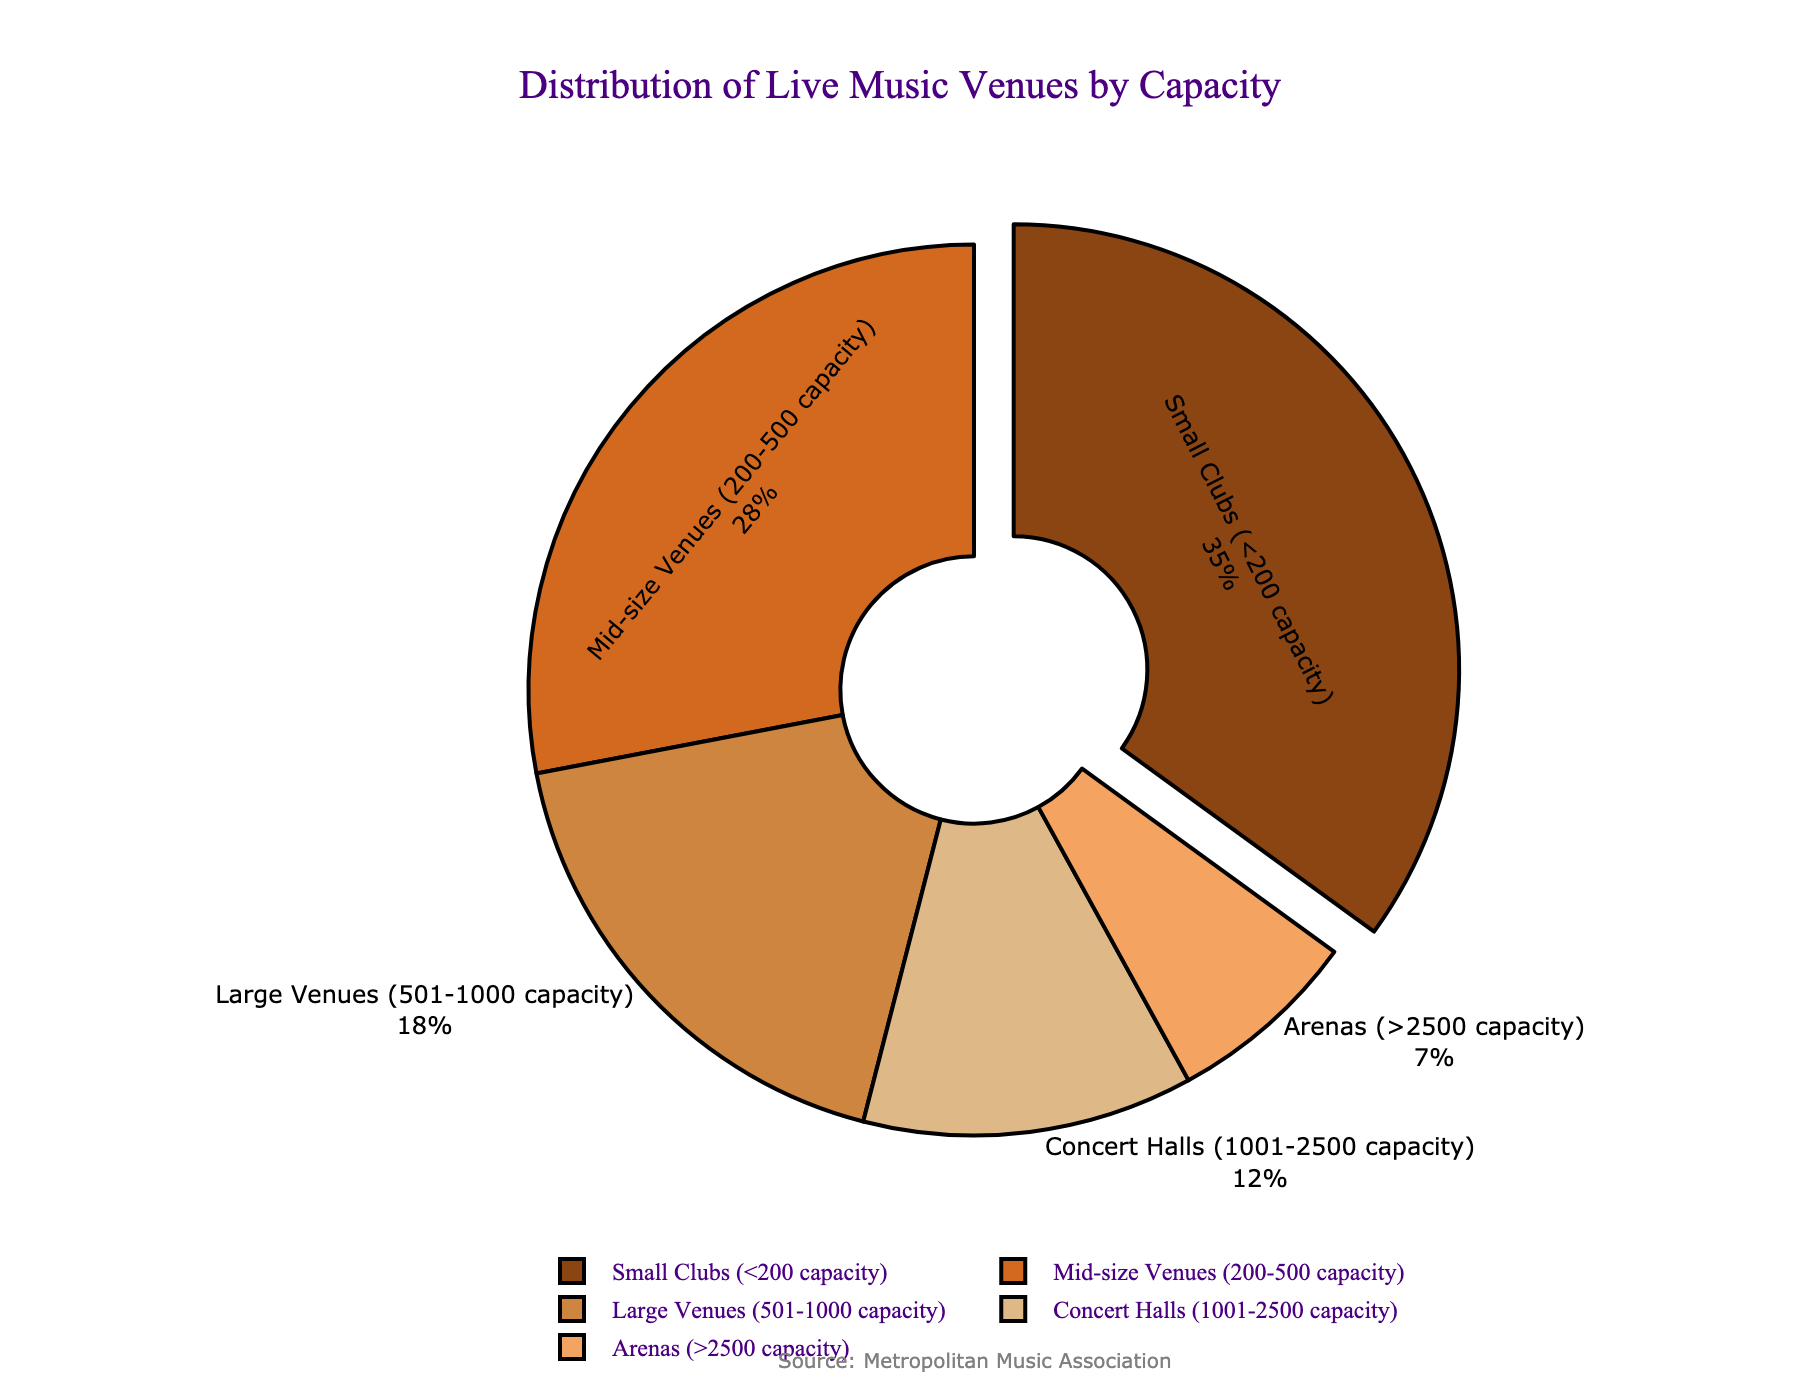What is the percentage of small clubs with less than 200 capacity? According to the pie chart, the percentage of small clubs with a capacity of less than 200 is explicitly listed as 35%.
Answer: 35% Which type of venues has the smallest percentage of live music venues? By inspecting the pie chart, arenas have the smallest segment, indicating that they hold the smallest percentage, which is 7%.
Answer: Arenas What is the combined percentage of mid-size venues and large venues? The percentage of mid-size venues is 28%, and large venues is 18%. Adding these together, 28% + 18% = 46%.
Answer: 46% Are there more small clubs or concert halls, and by what percentage difference? The pie chart shows that small clubs have 35%, and concert halls have 12%. The difference is calculated as 35% - 12% = 23%.
Answer: Small clubs by 23% Which venue type has more representation: large venues or concert halls? Inspecting the pie chart, large venues make up 18%, while concert halls make up 12%. Therefore, large venues have more representation.
Answer: Large venues What proportion of the venues have a capacity of over 1000 people (concert halls and arenas combined)? Concert halls are 12% and arenas are 7%. Adding these two, 12% + 7% = 19%.
Answer: 19% What is the visual effect used to highlight the section for small clubs? The pie chart uses a "pull" effect to slightly separate the small clubs section from the rest of the pie.
Answer: Pull effect How many venue types are shown in the pie chart? By counting the segments in the pie chart, there are five distinct venue types shown.
Answer: Five 